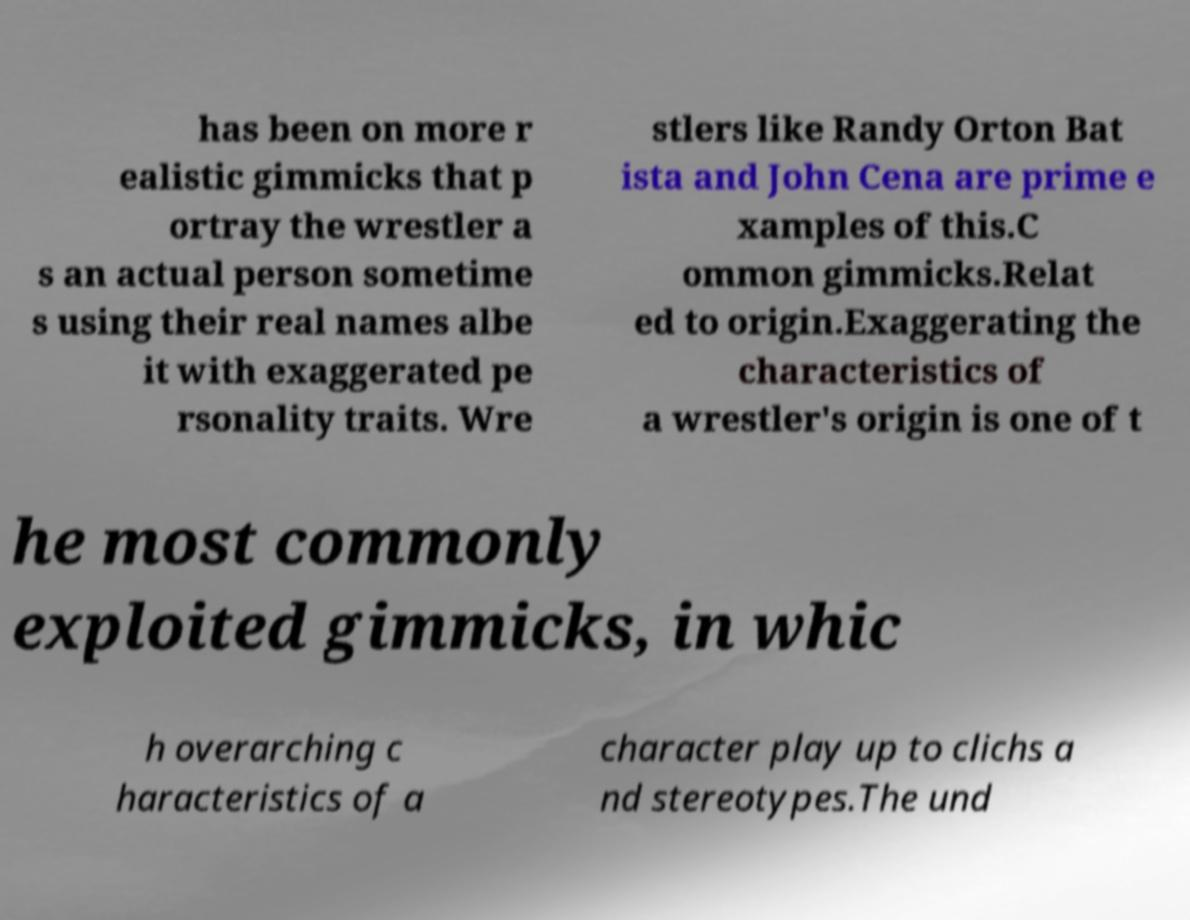Please identify and transcribe the text found in this image. has been on more r ealistic gimmicks that p ortray the wrestler a s an actual person sometime s using their real names albe it with exaggerated pe rsonality traits. Wre stlers like Randy Orton Bat ista and John Cena are prime e xamples of this.C ommon gimmicks.Relat ed to origin.Exaggerating the characteristics of a wrestler's origin is one of t he most commonly exploited gimmicks, in whic h overarching c haracteristics of a character play up to clichs a nd stereotypes.The und 